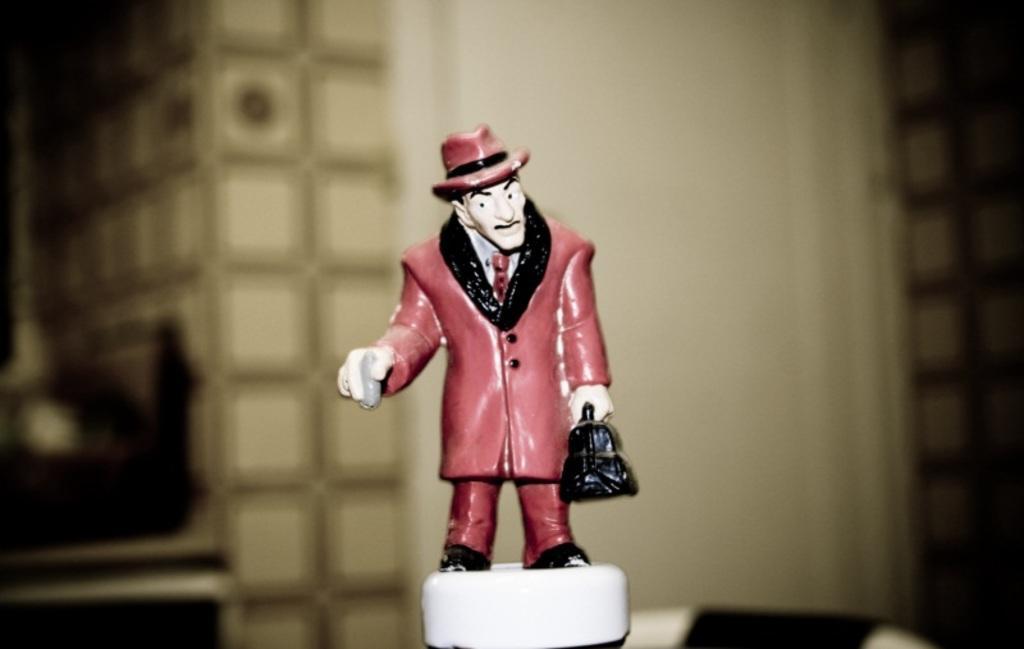Describe this image in one or two sentences. In this image I can see a statue in the shape of a man, this person wears a coat, trouser and a hat. 